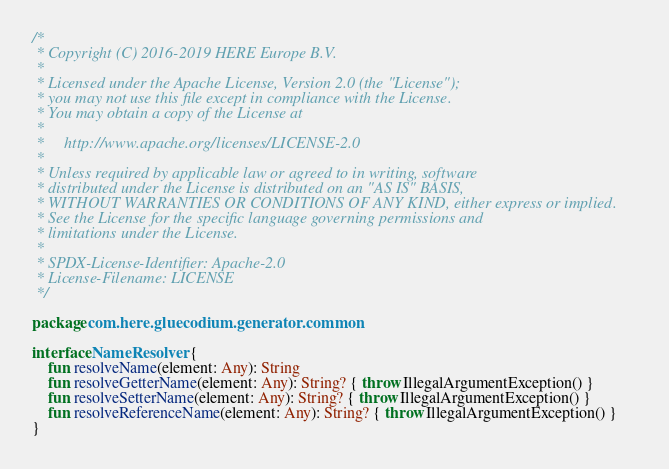Convert code to text. <code><loc_0><loc_0><loc_500><loc_500><_Kotlin_>/*
 * Copyright (C) 2016-2019 HERE Europe B.V.
 *
 * Licensed under the Apache License, Version 2.0 (the "License");
 * you may not use this file except in compliance with the License.
 * You may obtain a copy of the License at
 *
 *     http://www.apache.org/licenses/LICENSE-2.0
 *
 * Unless required by applicable law or agreed to in writing, software
 * distributed under the License is distributed on an "AS IS" BASIS,
 * WITHOUT WARRANTIES OR CONDITIONS OF ANY KIND, either express or implied.
 * See the License for the specific language governing permissions and
 * limitations under the License.
 *
 * SPDX-License-Identifier: Apache-2.0
 * License-Filename: LICENSE
 */

package com.here.gluecodium.generator.common

interface NameResolver {
    fun resolveName(element: Any): String
    fun resolveGetterName(element: Any): String? { throw IllegalArgumentException() }
    fun resolveSetterName(element: Any): String? { throw IllegalArgumentException() }
    fun resolveReferenceName(element: Any): String? { throw IllegalArgumentException() }
}
</code> 